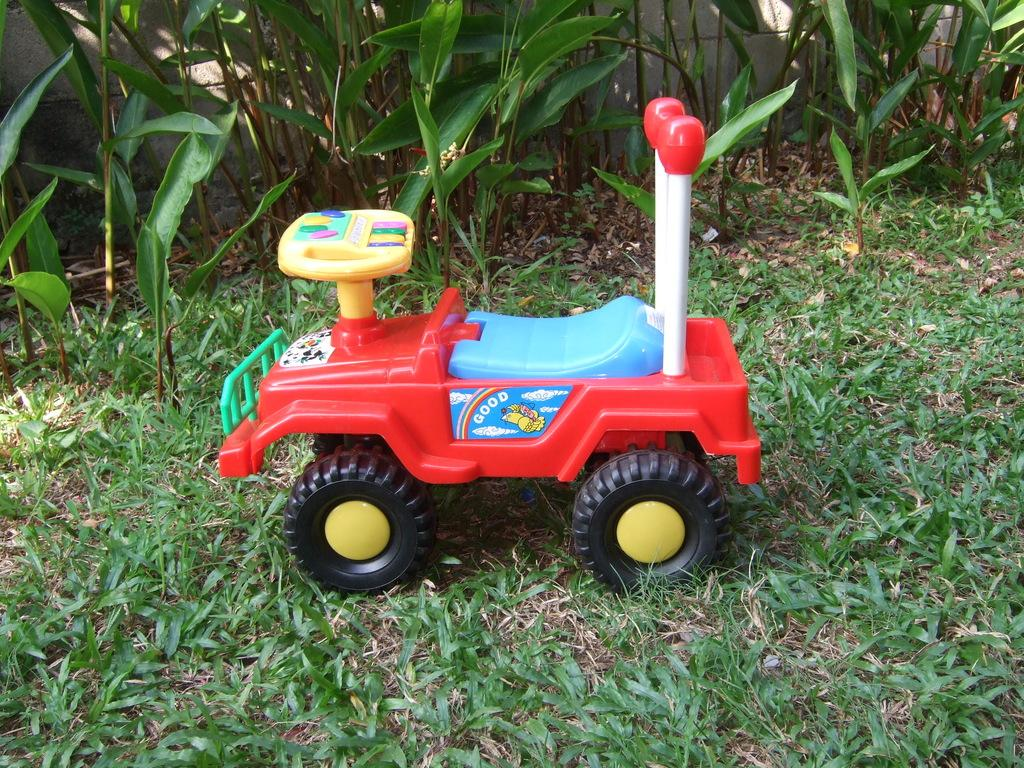What object is on the ground in the image? There is a toy car on the ground in the image. What type of terrain is visible in the image? There is grass visible in the image. What type of vegetation is present in the image? There are plants in the image. Is the toy car stuck in quicksand in the image? No, there is no quicksand present in the image. The toy car is on the grass. Can you see a chessboard in the image? No, there is no chessboard present in the image. Is there a scarecrow in the image? No, there is no scarecrow present in the image. 